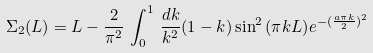Convert formula to latex. <formula><loc_0><loc_0><loc_500><loc_500>\Sigma _ { 2 } ( L ) = L - \frac { 2 } { \pi ^ { 2 } } \, \int _ { 0 } ^ { 1 } \, \frac { d k } { k ^ { 2 } } ( 1 - k ) \sin ^ { 2 } { ( \pi k L ) } e ^ { - ( \frac { a \pi k } { 2 } ) ^ { 2 } }</formula> 